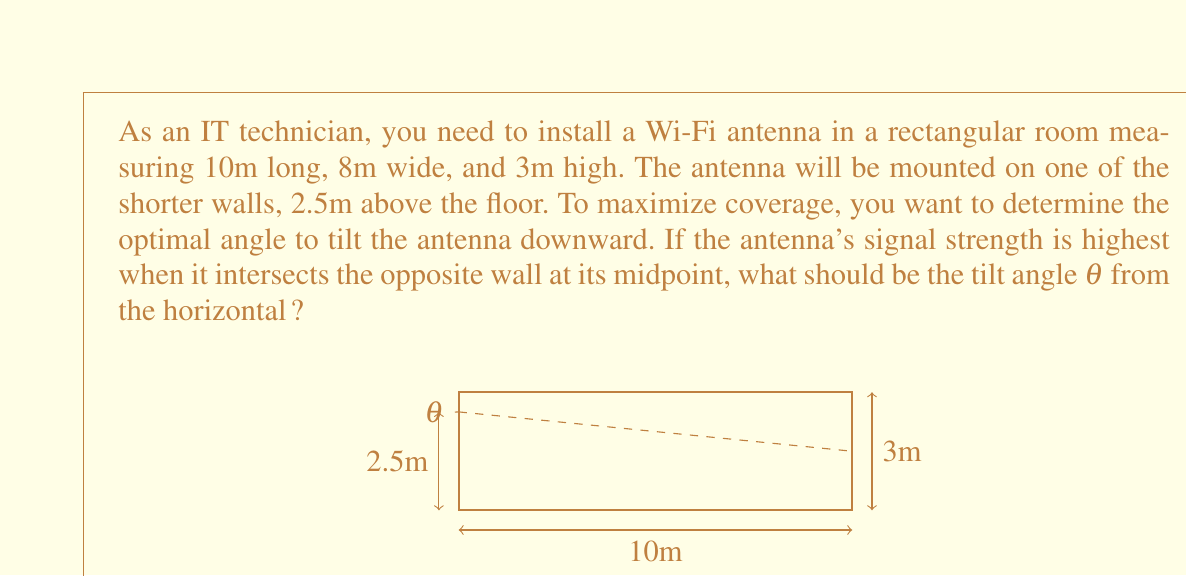Can you answer this question? To solve this problem, we'll use trigonometry:

1. First, let's identify the right triangle formed by the antenna's signal path:
   - The base of the triangle is the room's length: 10m
   - The height difference between the antenna mount and the midpoint of the opposite wall: 2.5m - 1.5m = 1m

2. We can use the arctangent function to find the angle:

   $$\theta = \arctan(\frac{\text{opposite}}{\text{adjacent}}) = \arctan(\frac{1m}{10m})$$

3. Using a calculator or programming function:

   $$\theta = \arctan(0.1) \approx 0.0997 \text{ radians}$$

4. Convert radians to degrees:

   $$\theta \approx 0.0997 \times \frac{180^{\circ}}{\pi} \approx 5.71^{\circ}$$

5. Round to the nearest degree for practical application:

   $$\theta \approx 6^{\circ}$$

This angle will ensure that the Wi-Fi signal intersects the opposite wall at its midpoint, potentially providing optimal coverage for the room.
Answer: The optimal tilt angle $\theta$ for the Wi-Fi antenna is approximately $6^{\circ}$ downward from the horizontal. 